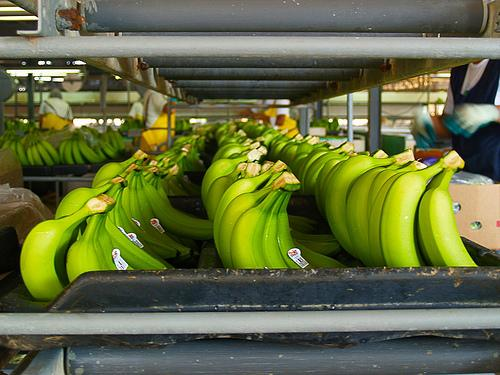What objects are being used to hold the bananas in rows in the factory? Sticks are used to hold the bananas in rows in the factory. Mention the color of the gloves worn by the workers in the image. The gloves are white with blue fingertips. What color and style is the uniform worn by the workers in the image? The workers are wearing blue and white uniforms. Explain the condition of the equipment found in the image. The equipment in the image appears old and rusty. How many yellow-green bananas can be identified in the image? There are 10 yellow-green bananas in the image. What type of fruit is being processed on the assembly line? Bananas are being processed on the assembly line. Identify the sticker color on the bananas and describe the emblem on it. The sticker on the bananas is white, with a red emblem. Provide a description of the person standing beside the bananas, including their wardrobe. The person standing beside the bananas is wearing a white shirt, blue vest, and white gloves with blue fingertips. List the personal protective equipment (PPE) utilized by the workers in the image. Hairnets, gloves, and aprons are the personal protective equipment (PPE) utilized by the workers in the image. Describe the color and condition of the metal bar in the image. The metal bar has rusty scratches and is gray in color. Describe the clothing of the person standing beside bananas in the picture. Blue vest, white shirt, and white gloves with blue fingertips. What color is the metal pole at X:23 Y:302 Width:455 Height:455? Gray. Identify the position of white labels on bananas in the image. X:108 Y:213 Width:57 Height:57 Describe the sentiment of the image with bananas being processed on the assembly line. Busy and productive atmosphere. What kind of equipment is located in the image at X:52 Y:4 Width:35 Height:35? A rusty piece of equipment. Can you notice the pigeon perched on one of the metal bars? There is no mention of a pigeon in the object list. Asking the user to find a pigeon would lead them to search for a nonexistent object in the image. Find the objects related to workers' attire in the image. Workers' hairnet, blue and white gloves, yellow apron, workers' blue and white uniform. Examine the image quality in terms of clarity and detail. The image has intricate detail and good clarity. Observe the worker wearing a pink hat working on the assembly line. No, it's not mentioned in the image. Determine the colors visible on the gloves of the person handling bananas. White and blue. Find the purple flag hanging from the ceiling in the background. There is no mention of a purple flag in the object list. Asking the user to find a purple flag would lead them to search for a nonexistent object and create confusion. Pinpoint the anomalies present in the image. Rusty piece of equipment and rusty scratches on the metal bar. Which image element is found at the given position: X:433 Y:151 Width:66 Height:66? A cardboard box on a cart. Locate the blue water bottle on the floor near the bananas. There is no mention of a water bottle in the list of objects in the image. Asking the user to find a water bottle would be misleading and could cause confusion. Explain the OCR found in the image. No OCR detected since there is no text in the image. What kind of sticker is on the bananas at X:283 Y:243 Width:27 Height:27? Merchants sticker with a red emblem. Demonstrate the interaction between the workers and the bananas in the image. Workers are handling and processing bananas on the assembly line and wearing gloves for hygiene. Out of the choices given, which best describes the person stocking the shelf: wearing a green vest, a blue vest, or no vest? Wearing a blue vest. Try to find the small kitten hidden among the bananas on the assembly line. There is no mention of a kitten in the list of objects in the image, so asking the user to find a kitten would be misleading. List the main objects displayed in the image. Bananas, workers, assembly line, and packaging materials. Identify the colors of bananas in the image. Yellow green. Which tasks are workers doing in the image? Working on the assembly line, stocking bananas, and putting bananas in boxes. Find the sentiment expressed by the scene of a large group of bananas. Abundance and productivity. Are there any visible bolts in the image? If so, what are their coordinates? Yes, two silver bolts at X:449 Y:202 Width:38 Height:38. Identify the red fire extinguisher placed next to the rusty piece of equipment. There is no mention of a fire extinguisher in the objects' list. Asking the user to find a fire extinguisher would lead them to search for a nonexistent object. 